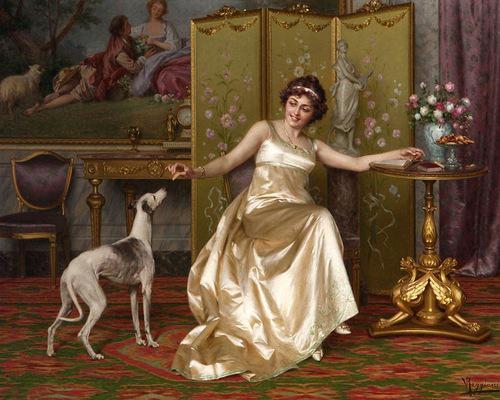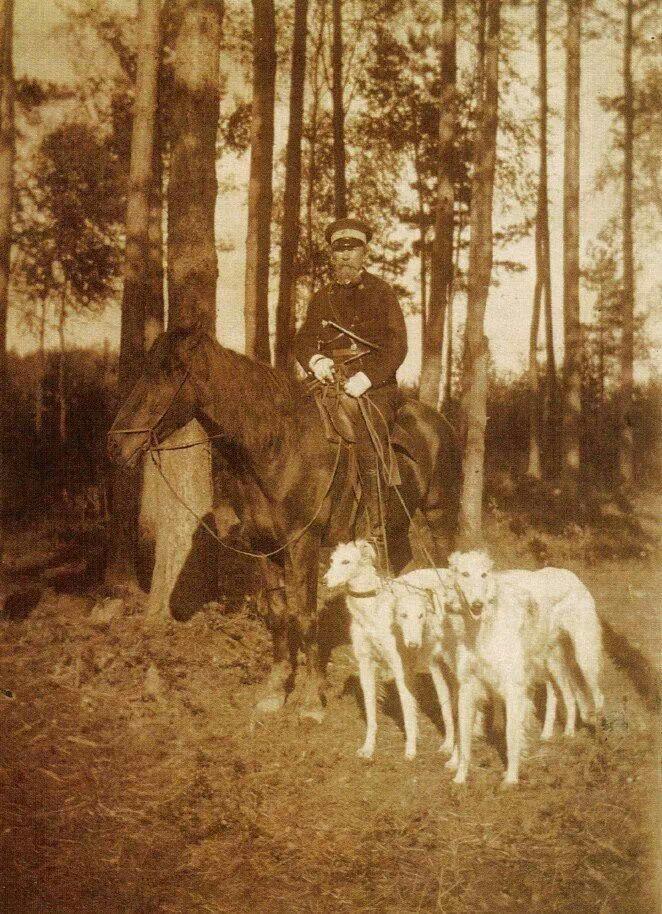The first image is the image on the left, the second image is the image on the right. Examine the images to the left and right. Is the description "There is a woman sitting down with a dog next to her." accurate? Answer yes or no. Yes. The first image is the image on the left, the second image is the image on the right. Assess this claim about the two images: "In at least one image there is a single female in a dress sit in a chair next to her white dog.". Correct or not? Answer yes or no. Yes. 